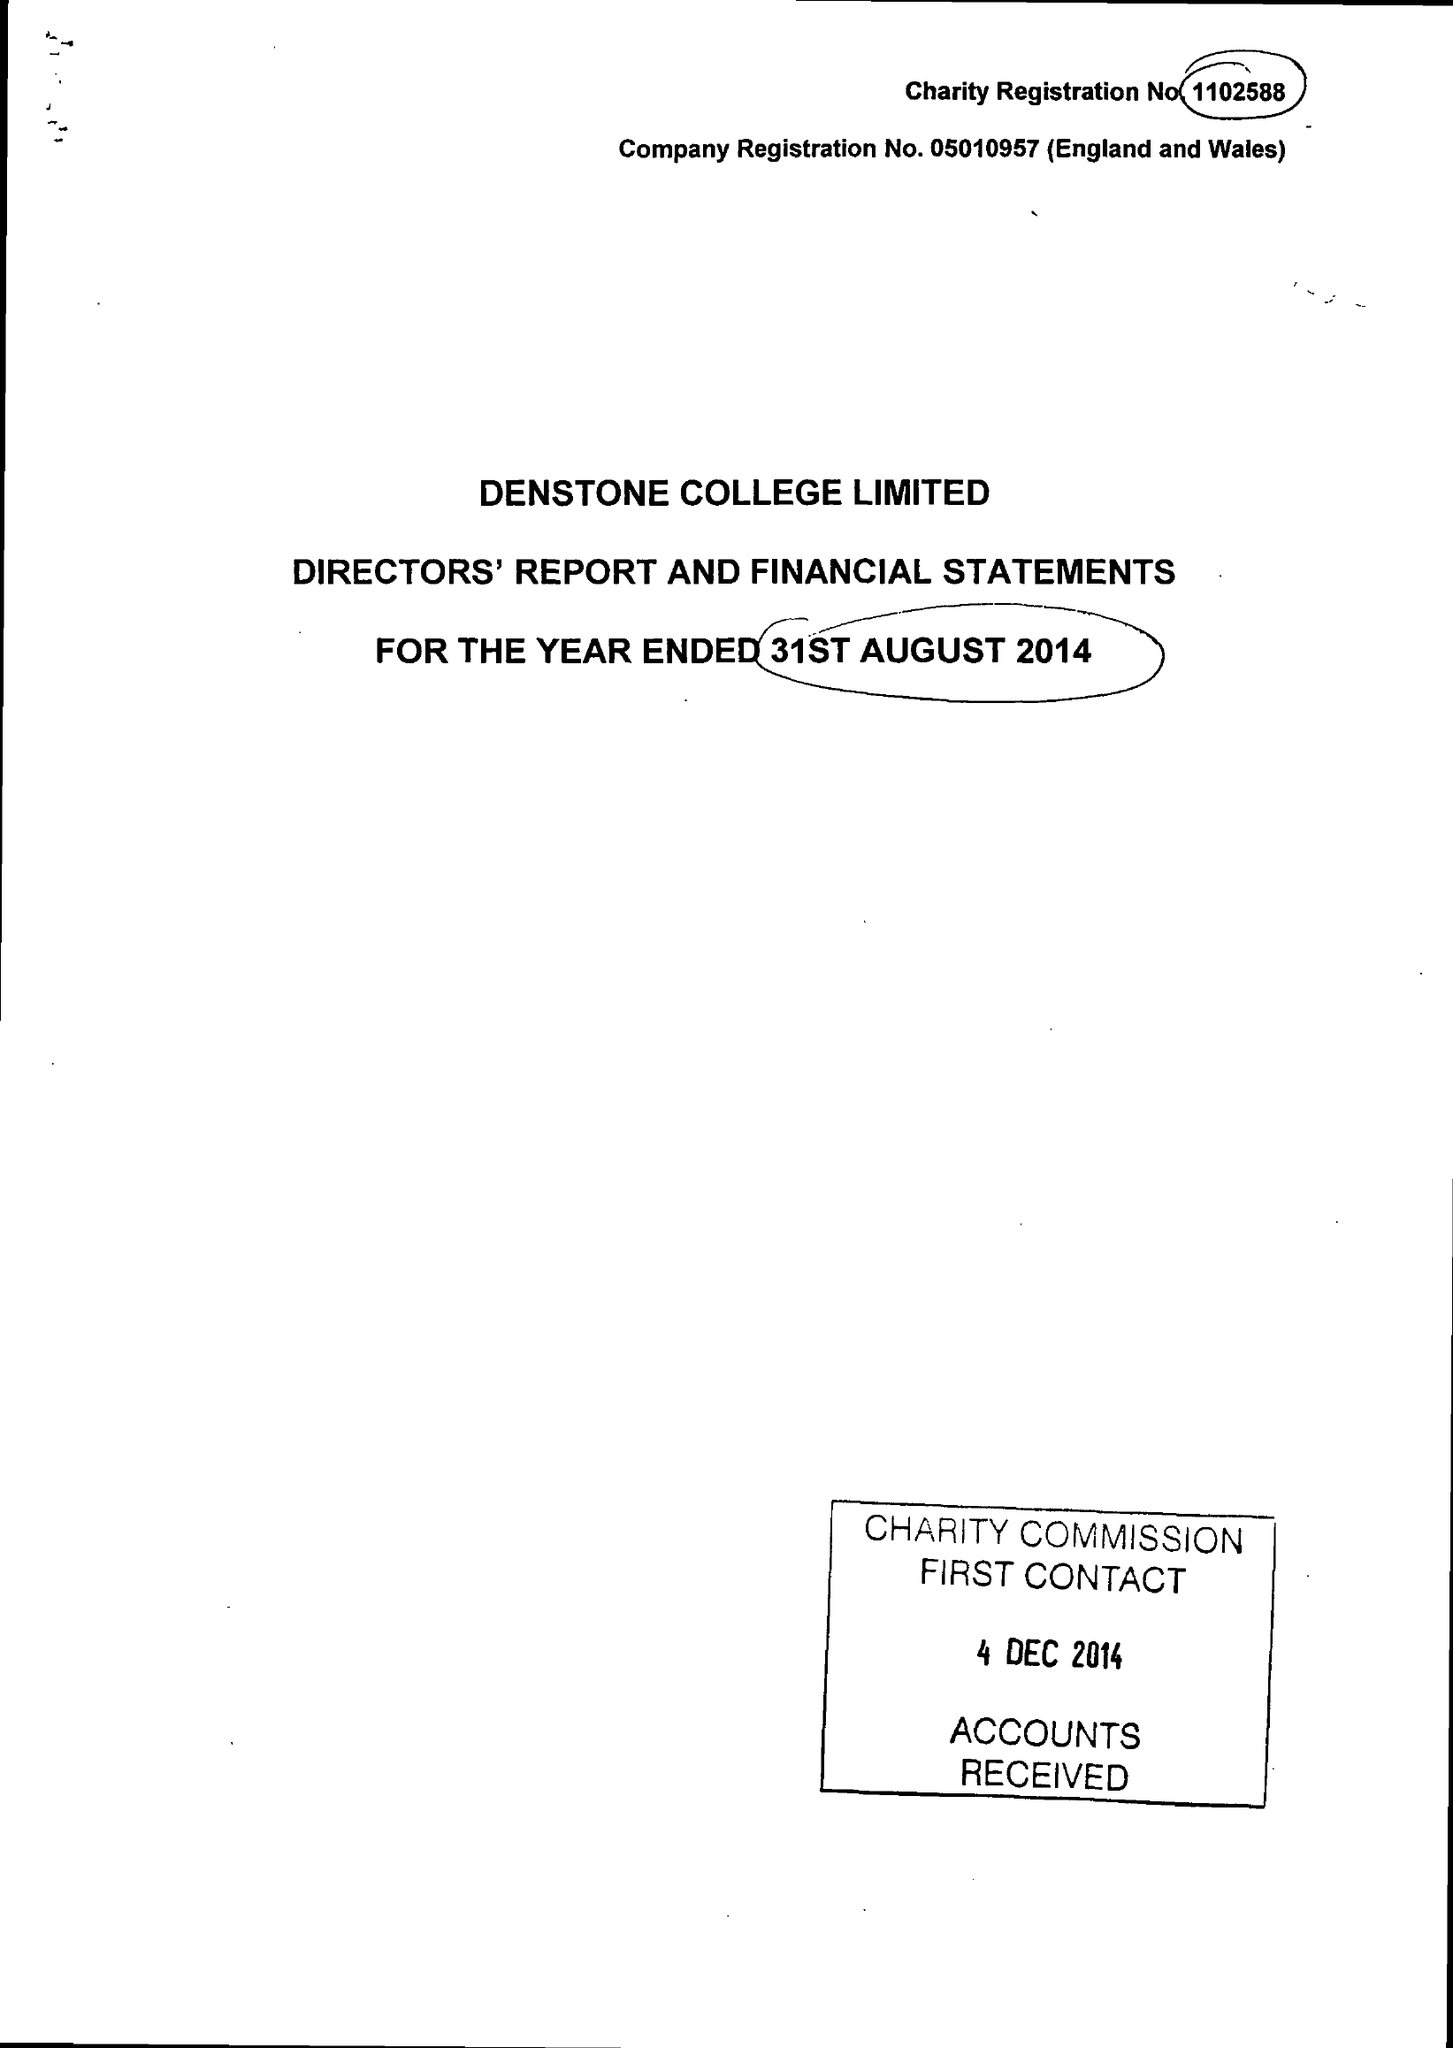What is the value for the charity_name?
Answer the question using a single word or phrase. Denstone College Ltd. 